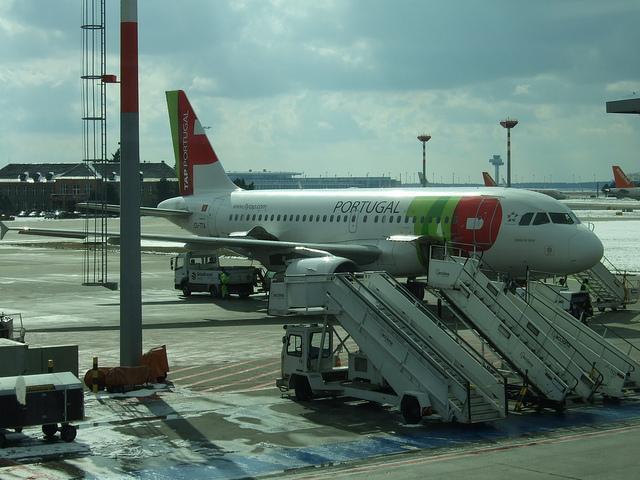How many trucks are in the photo?
Give a very brief answer. 2. 